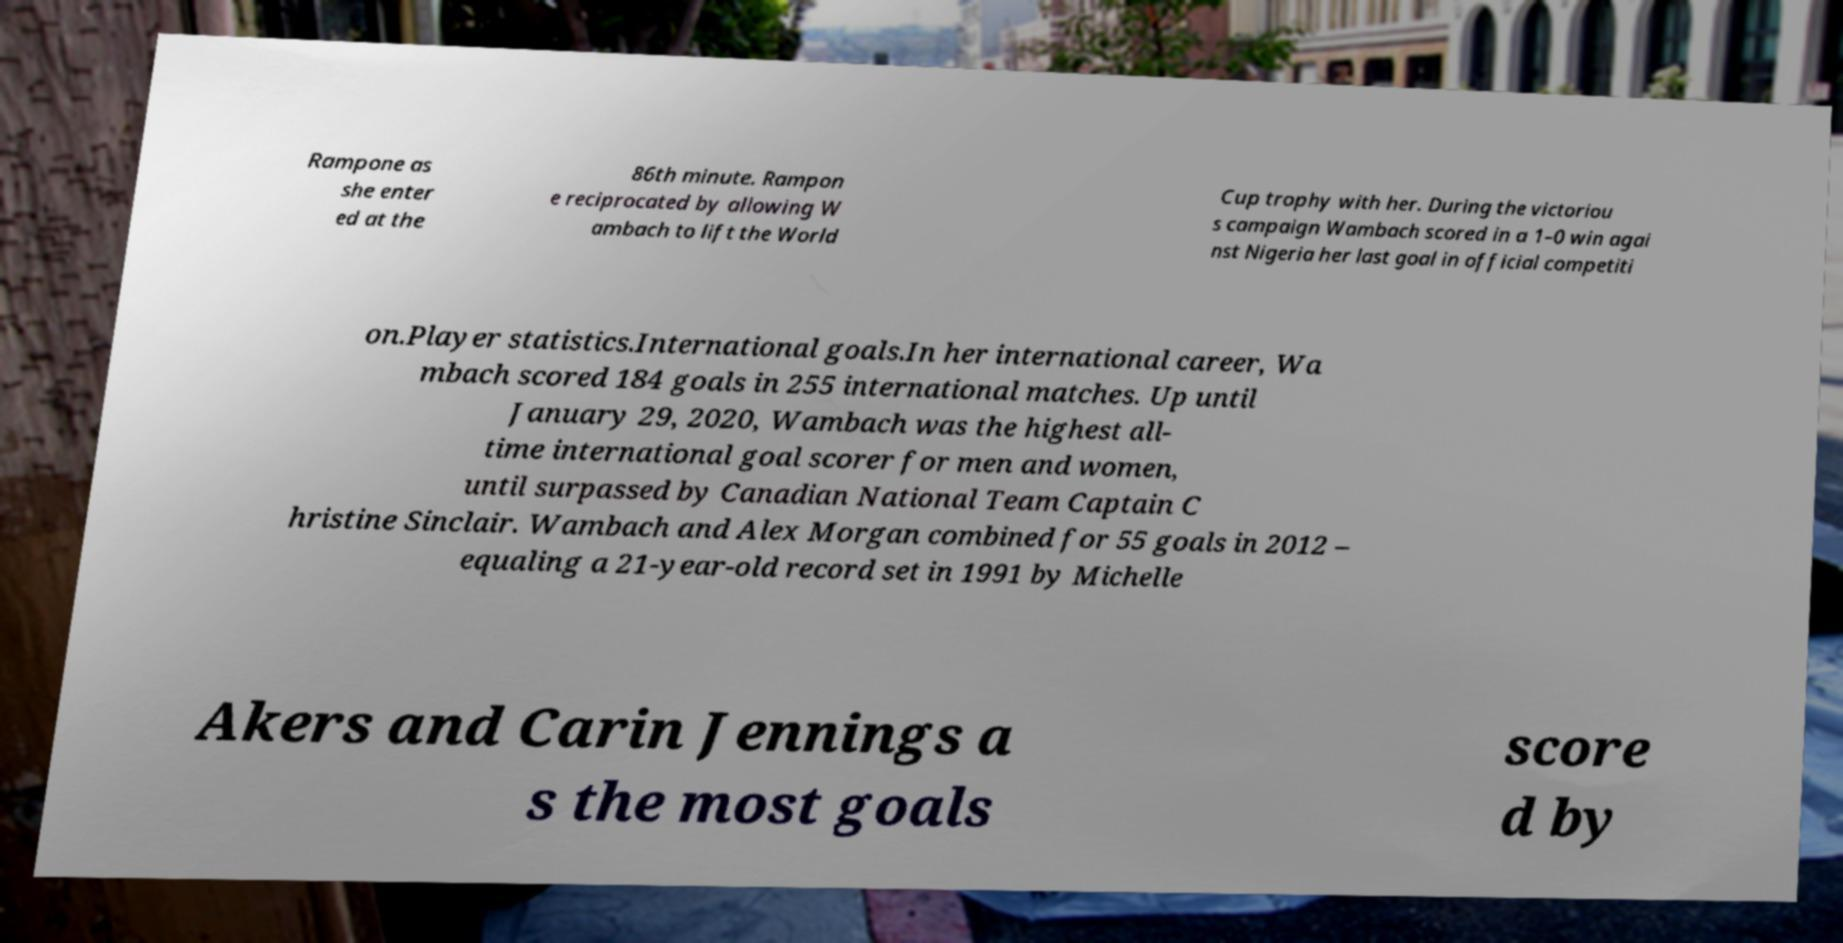Please identify and transcribe the text found in this image. Rampone as she enter ed at the 86th minute. Rampon e reciprocated by allowing W ambach to lift the World Cup trophy with her. During the victoriou s campaign Wambach scored in a 1–0 win agai nst Nigeria her last goal in official competiti on.Player statistics.International goals.In her international career, Wa mbach scored 184 goals in 255 international matches. Up until January 29, 2020, Wambach was the highest all- time international goal scorer for men and women, until surpassed by Canadian National Team Captain C hristine Sinclair. Wambach and Alex Morgan combined for 55 goals in 2012 – equaling a 21-year-old record set in 1991 by Michelle Akers and Carin Jennings a s the most goals score d by 